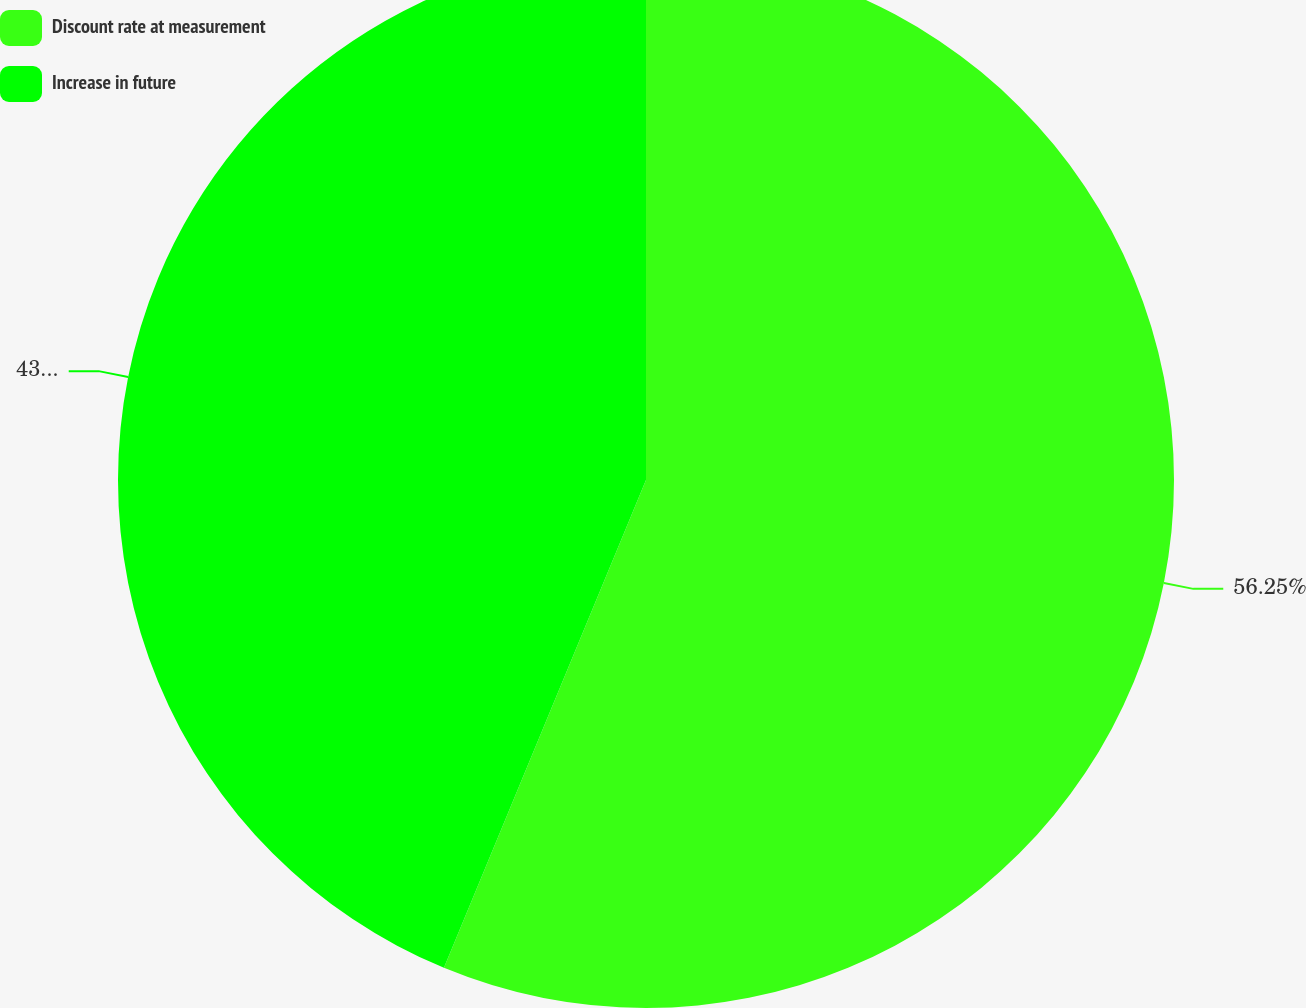Convert chart to OTSL. <chart><loc_0><loc_0><loc_500><loc_500><pie_chart><fcel>Discount rate at measurement<fcel>Increase in future<nl><fcel>56.25%<fcel>43.75%<nl></chart> 